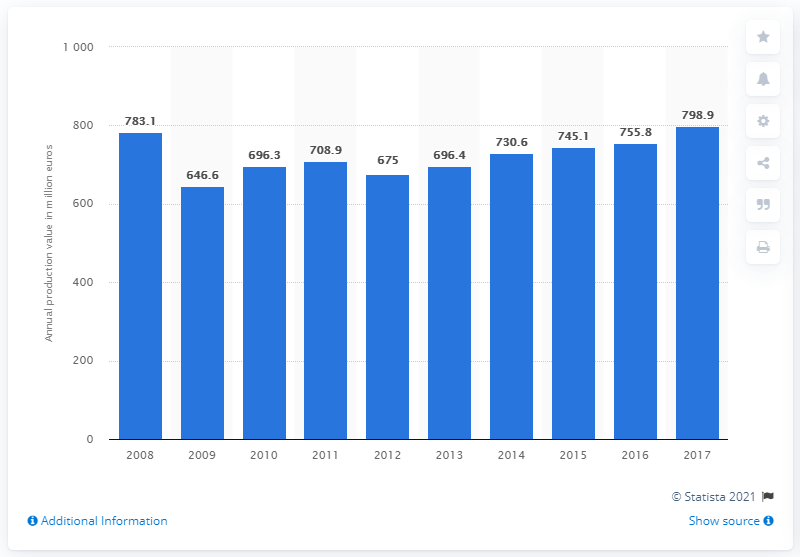Highlight a few significant elements in this photo. The Slovenian production value of paper and paper products in 2017 was 798.9 million euros. 